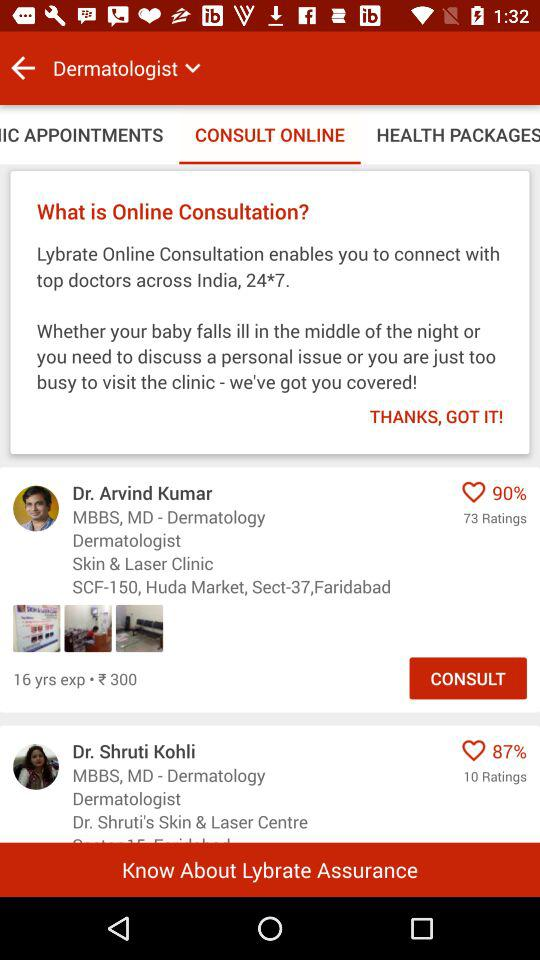How many years of experience does Dr. Shruti Kohli have?
When the provided information is insufficient, respond with <no answer>. <no answer> 